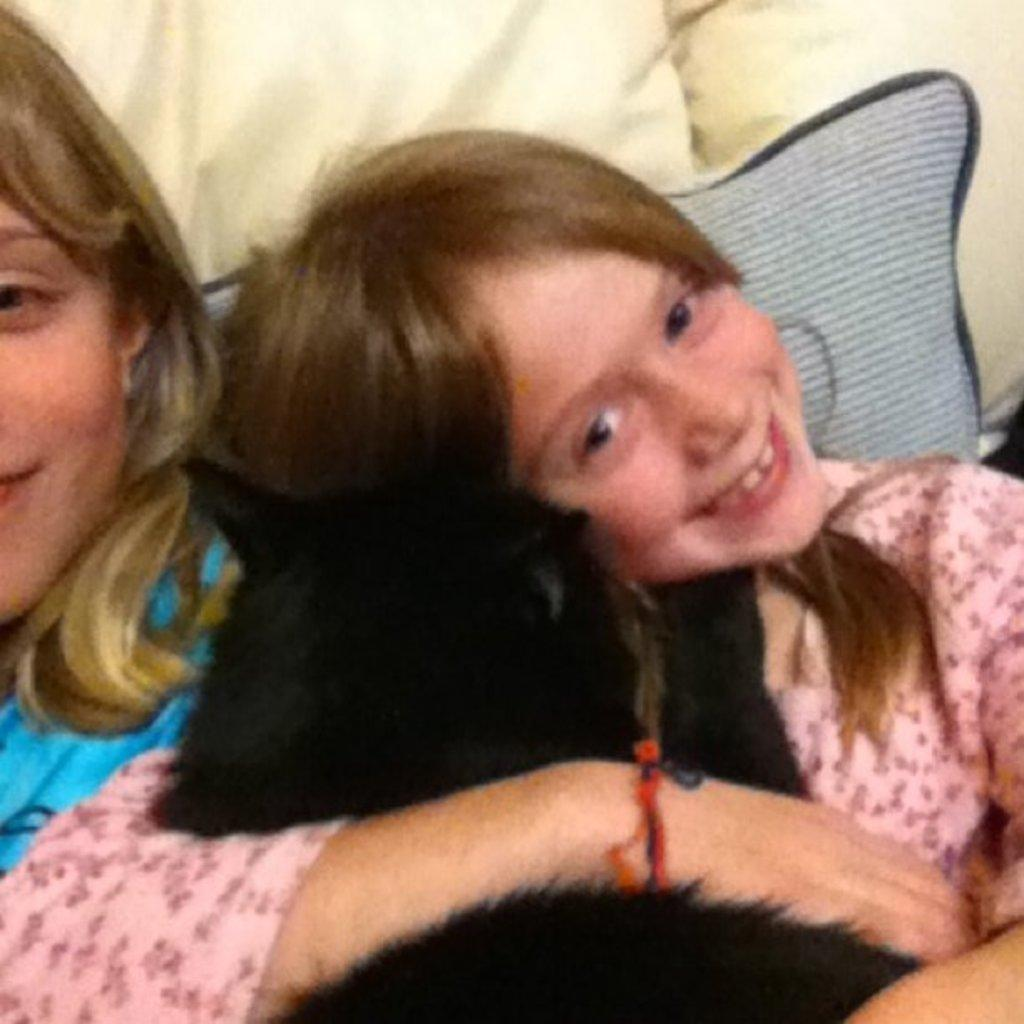How many people are in the image? There are two girls in the image. What are the girls wearing? The girls are wearing clothes. What expression do the girls have? The girls are smiling. What can be seen in the background or foreground of the image? There are pillows visible in the image. What type of cattle can be seen in the image? There are no cattle present in the image; it features two girls and pillows. What kind of noise can be heard coming from the girls in the image? There is no indication of any noise in the image, as it only shows the girls' facial expressions and the presence of pillows. 